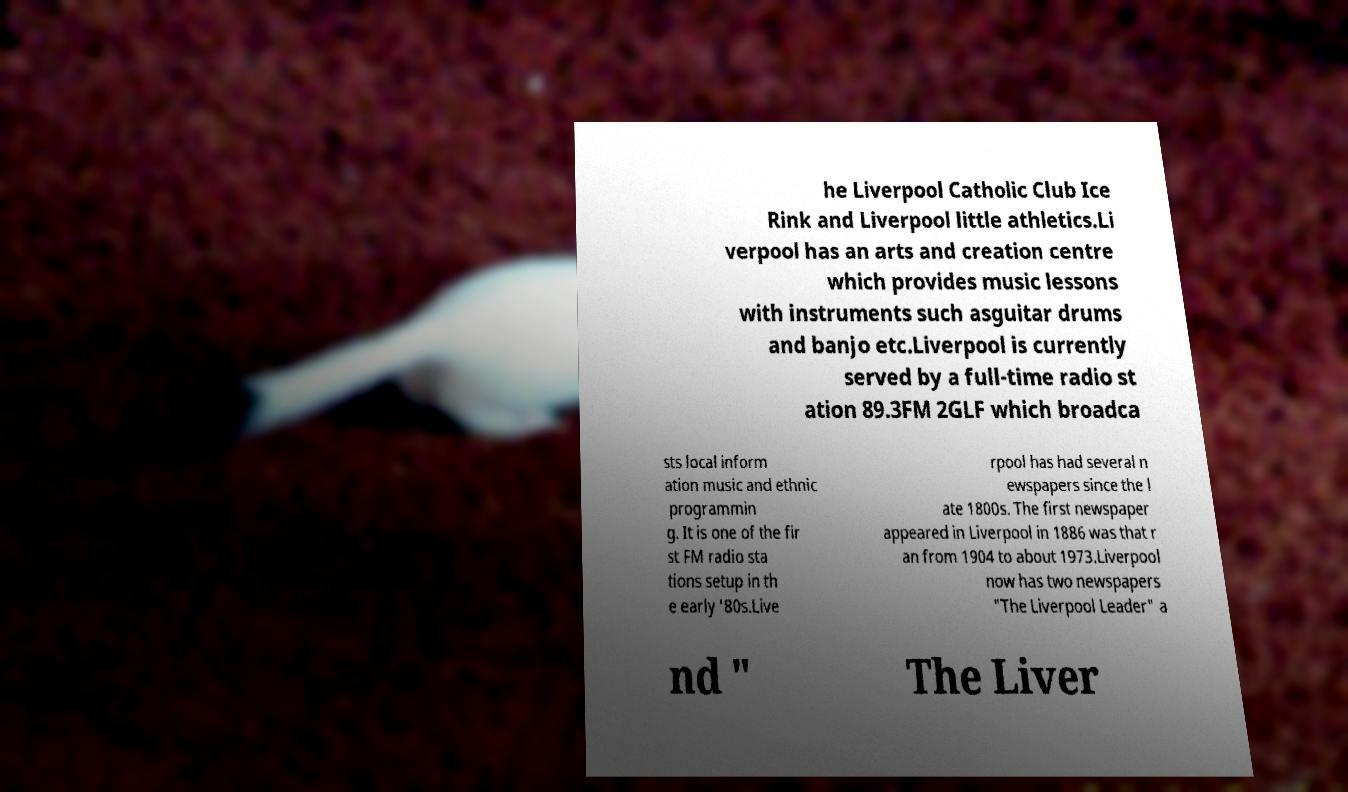Could you assist in decoding the text presented in this image and type it out clearly? he Liverpool Catholic Club Ice Rink and Liverpool little athletics.Li verpool has an arts and creation centre which provides music lessons with instruments such asguitar drums and banjo etc.Liverpool is currently served by a full-time radio st ation 89.3FM 2GLF which broadca sts local inform ation music and ethnic programmin g. It is one of the fir st FM radio sta tions setup in th e early '80s.Live rpool has had several n ewspapers since the l ate 1800s. The first newspaper appeared in Liverpool in 1886 was that r an from 1904 to about 1973.Liverpool now has two newspapers "The Liverpool Leader" a nd " The Liver 